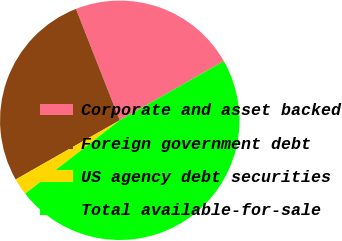<chart> <loc_0><loc_0><loc_500><loc_500><pie_chart><fcel>Corporate and asset backed<fcel>Foreign government debt<fcel>US agency debt securities<fcel>Total available-for-sale<nl><fcel>22.73%<fcel>27.27%<fcel>2.27%<fcel>47.73%<nl></chart> 